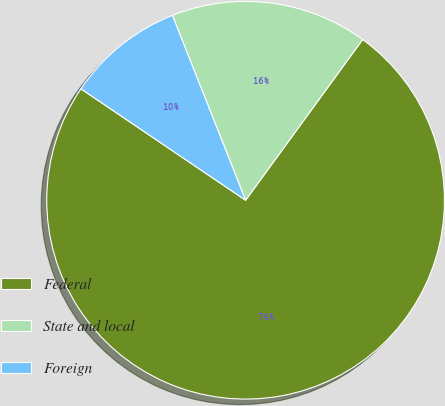<chart> <loc_0><loc_0><loc_500><loc_500><pie_chart><fcel>Federal<fcel>State and local<fcel>Foreign<nl><fcel>74.45%<fcel>16.02%<fcel>9.53%<nl></chart> 